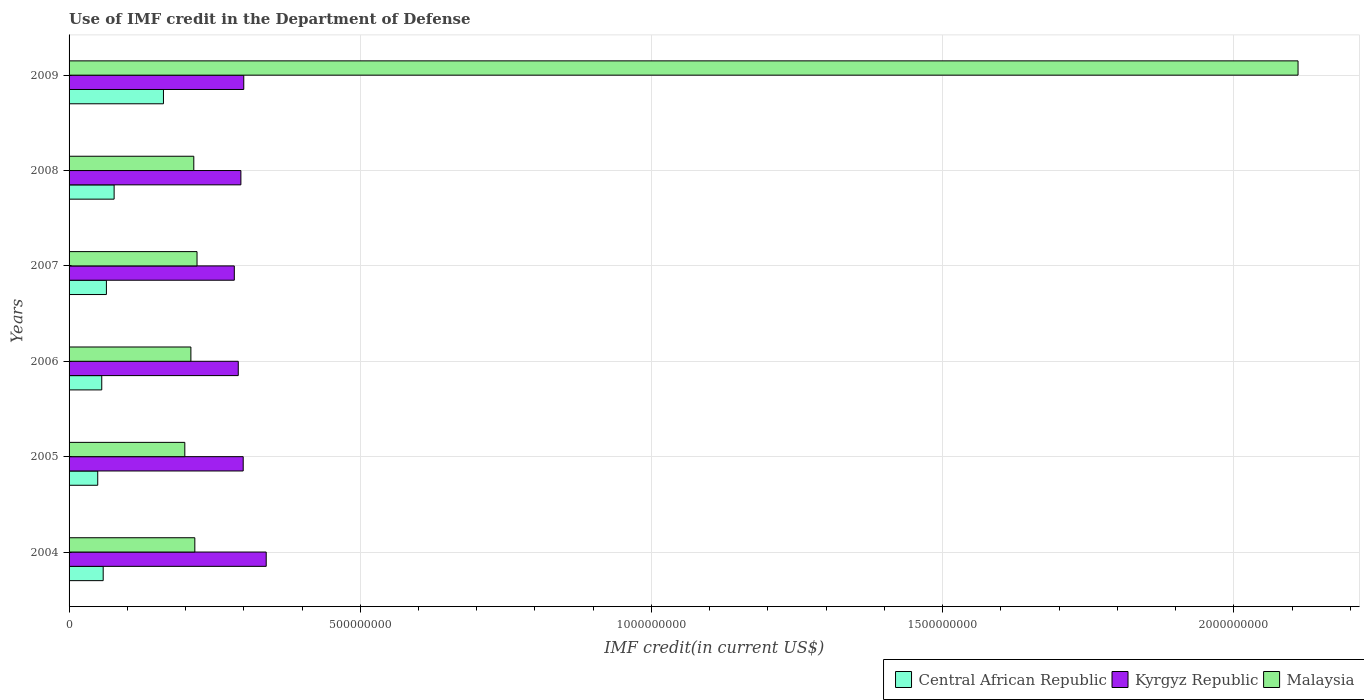How many different coloured bars are there?
Offer a very short reply. 3. Are the number of bars per tick equal to the number of legend labels?
Ensure brevity in your answer.  Yes. What is the IMF credit in the Department of Defense in Central African Republic in 2007?
Your answer should be very brief. 6.41e+07. Across all years, what is the maximum IMF credit in the Department of Defense in Central African Republic?
Your answer should be compact. 1.62e+08. Across all years, what is the minimum IMF credit in the Department of Defense in Central African Republic?
Your response must be concise. 4.92e+07. In which year was the IMF credit in the Department of Defense in Malaysia maximum?
Make the answer very short. 2009. In which year was the IMF credit in the Department of Defense in Malaysia minimum?
Give a very brief answer. 2005. What is the total IMF credit in the Department of Defense in Kyrgyz Republic in the graph?
Provide a succinct answer. 1.81e+09. What is the difference between the IMF credit in the Department of Defense in Kyrgyz Republic in 2004 and that in 2008?
Give a very brief answer. 4.35e+07. What is the difference between the IMF credit in the Department of Defense in Kyrgyz Republic in 2004 and the IMF credit in the Department of Defense in Malaysia in 2008?
Provide a succinct answer. 1.24e+08. What is the average IMF credit in the Department of Defense in Kyrgyz Republic per year?
Your answer should be compact. 3.01e+08. In the year 2009, what is the difference between the IMF credit in the Department of Defense in Kyrgyz Republic and IMF credit in the Department of Defense in Central African Republic?
Give a very brief answer. 1.38e+08. What is the ratio of the IMF credit in the Department of Defense in Central African Republic in 2007 to that in 2008?
Provide a short and direct response. 0.83. Is the IMF credit in the Department of Defense in Malaysia in 2004 less than that in 2007?
Your answer should be compact. Yes. What is the difference between the highest and the second highest IMF credit in the Department of Defense in Central African Republic?
Offer a very short reply. 8.47e+07. What is the difference between the highest and the lowest IMF credit in the Department of Defense in Kyrgyz Republic?
Keep it short and to the point. 5.48e+07. What does the 2nd bar from the top in 2009 represents?
Offer a terse response. Kyrgyz Republic. What does the 2nd bar from the bottom in 2005 represents?
Offer a terse response. Kyrgyz Republic. How many years are there in the graph?
Provide a succinct answer. 6. Does the graph contain grids?
Ensure brevity in your answer.  Yes. Where does the legend appear in the graph?
Make the answer very short. Bottom right. How many legend labels are there?
Provide a succinct answer. 3. What is the title of the graph?
Your answer should be very brief. Use of IMF credit in the Department of Defense. What is the label or title of the X-axis?
Offer a terse response. IMF credit(in current US$). What is the label or title of the Y-axis?
Your response must be concise. Years. What is the IMF credit(in current US$) in Central African Republic in 2004?
Keep it short and to the point. 5.86e+07. What is the IMF credit(in current US$) of Kyrgyz Republic in 2004?
Your response must be concise. 3.39e+08. What is the IMF credit(in current US$) of Malaysia in 2004?
Provide a succinct answer. 2.16e+08. What is the IMF credit(in current US$) of Central African Republic in 2005?
Your answer should be compact. 4.92e+07. What is the IMF credit(in current US$) of Kyrgyz Republic in 2005?
Keep it short and to the point. 2.99e+08. What is the IMF credit(in current US$) of Malaysia in 2005?
Keep it short and to the point. 1.99e+08. What is the IMF credit(in current US$) in Central African Republic in 2006?
Provide a short and direct response. 5.61e+07. What is the IMF credit(in current US$) in Kyrgyz Republic in 2006?
Your answer should be very brief. 2.91e+08. What is the IMF credit(in current US$) in Malaysia in 2006?
Make the answer very short. 2.09e+08. What is the IMF credit(in current US$) of Central African Republic in 2007?
Give a very brief answer. 6.41e+07. What is the IMF credit(in current US$) of Kyrgyz Republic in 2007?
Your answer should be compact. 2.84e+08. What is the IMF credit(in current US$) of Malaysia in 2007?
Provide a short and direct response. 2.20e+08. What is the IMF credit(in current US$) of Central African Republic in 2008?
Your response must be concise. 7.74e+07. What is the IMF credit(in current US$) of Kyrgyz Republic in 2008?
Provide a succinct answer. 2.95e+08. What is the IMF credit(in current US$) of Malaysia in 2008?
Provide a succinct answer. 2.14e+08. What is the IMF credit(in current US$) of Central African Republic in 2009?
Offer a terse response. 1.62e+08. What is the IMF credit(in current US$) of Kyrgyz Republic in 2009?
Offer a terse response. 3.00e+08. What is the IMF credit(in current US$) of Malaysia in 2009?
Provide a succinct answer. 2.11e+09. Across all years, what is the maximum IMF credit(in current US$) of Central African Republic?
Keep it short and to the point. 1.62e+08. Across all years, what is the maximum IMF credit(in current US$) of Kyrgyz Republic?
Your response must be concise. 3.39e+08. Across all years, what is the maximum IMF credit(in current US$) of Malaysia?
Provide a short and direct response. 2.11e+09. Across all years, what is the minimum IMF credit(in current US$) of Central African Republic?
Make the answer very short. 4.92e+07. Across all years, what is the minimum IMF credit(in current US$) in Kyrgyz Republic?
Provide a short and direct response. 2.84e+08. Across all years, what is the minimum IMF credit(in current US$) of Malaysia?
Give a very brief answer. 1.99e+08. What is the total IMF credit(in current US$) in Central African Republic in the graph?
Your response must be concise. 4.67e+08. What is the total IMF credit(in current US$) in Kyrgyz Republic in the graph?
Give a very brief answer. 1.81e+09. What is the total IMF credit(in current US$) in Malaysia in the graph?
Your answer should be compact. 3.17e+09. What is the difference between the IMF credit(in current US$) in Central African Republic in 2004 and that in 2005?
Keep it short and to the point. 9.38e+06. What is the difference between the IMF credit(in current US$) in Kyrgyz Republic in 2004 and that in 2005?
Keep it short and to the point. 3.95e+07. What is the difference between the IMF credit(in current US$) in Malaysia in 2004 and that in 2005?
Provide a succinct answer. 1.72e+07. What is the difference between the IMF credit(in current US$) of Central African Republic in 2004 and that in 2006?
Your response must be concise. 2.48e+06. What is the difference between the IMF credit(in current US$) of Kyrgyz Republic in 2004 and that in 2006?
Offer a terse response. 4.80e+07. What is the difference between the IMF credit(in current US$) in Malaysia in 2004 and that in 2006?
Make the answer very short. 6.76e+06. What is the difference between the IMF credit(in current US$) in Central African Republic in 2004 and that in 2007?
Ensure brevity in your answer.  -5.52e+06. What is the difference between the IMF credit(in current US$) in Kyrgyz Republic in 2004 and that in 2007?
Offer a terse response. 5.48e+07. What is the difference between the IMF credit(in current US$) of Malaysia in 2004 and that in 2007?
Ensure brevity in your answer.  -3.79e+06. What is the difference between the IMF credit(in current US$) in Central African Republic in 2004 and that in 2008?
Offer a terse response. -1.88e+07. What is the difference between the IMF credit(in current US$) in Kyrgyz Republic in 2004 and that in 2008?
Keep it short and to the point. 4.35e+07. What is the difference between the IMF credit(in current US$) in Malaysia in 2004 and that in 2008?
Keep it short and to the point. 1.77e+06. What is the difference between the IMF credit(in current US$) of Central African Republic in 2004 and that in 2009?
Keep it short and to the point. -1.03e+08. What is the difference between the IMF credit(in current US$) in Kyrgyz Republic in 2004 and that in 2009?
Your answer should be compact. 3.86e+07. What is the difference between the IMF credit(in current US$) in Malaysia in 2004 and that in 2009?
Give a very brief answer. -1.89e+09. What is the difference between the IMF credit(in current US$) of Central African Republic in 2005 and that in 2006?
Make the answer very short. -6.90e+06. What is the difference between the IMF credit(in current US$) of Kyrgyz Republic in 2005 and that in 2006?
Give a very brief answer. 8.46e+06. What is the difference between the IMF credit(in current US$) of Malaysia in 2005 and that in 2006?
Your answer should be compact. -1.04e+07. What is the difference between the IMF credit(in current US$) in Central African Republic in 2005 and that in 2007?
Your answer should be very brief. -1.49e+07. What is the difference between the IMF credit(in current US$) in Kyrgyz Republic in 2005 and that in 2007?
Your response must be concise. 1.53e+07. What is the difference between the IMF credit(in current US$) in Malaysia in 2005 and that in 2007?
Give a very brief answer. -2.10e+07. What is the difference between the IMF credit(in current US$) in Central African Republic in 2005 and that in 2008?
Give a very brief answer. -2.82e+07. What is the difference between the IMF credit(in current US$) in Kyrgyz Republic in 2005 and that in 2008?
Your answer should be very brief. 3.97e+06. What is the difference between the IMF credit(in current US$) in Malaysia in 2005 and that in 2008?
Offer a terse response. -1.54e+07. What is the difference between the IMF credit(in current US$) of Central African Republic in 2005 and that in 2009?
Make the answer very short. -1.13e+08. What is the difference between the IMF credit(in current US$) of Kyrgyz Republic in 2005 and that in 2009?
Provide a succinct answer. -9.68e+05. What is the difference between the IMF credit(in current US$) of Malaysia in 2005 and that in 2009?
Keep it short and to the point. -1.91e+09. What is the difference between the IMF credit(in current US$) of Central African Republic in 2006 and that in 2007?
Provide a succinct answer. -8.00e+06. What is the difference between the IMF credit(in current US$) in Kyrgyz Republic in 2006 and that in 2007?
Offer a very short reply. 6.81e+06. What is the difference between the IMF credit(in current US$) in Malaysia in 2006 and that in 2007?
Your response must be concise. -1.05e+07. What is the difference between the IMF credit(in current US$) in Central African Republic in 2006 and that in 2008?
Your answer should be compact. -2.13e+07. What is the difference between the IMF credit(in current US$) in Kyrgyz Republic in 2006 and that in 2008?
Your answer should be very brief. -4.50e+06. What is the difference between the IMF credit(in current US$) of Malaysia in 2006 and that in 2008?
Give a very brief answer. -4.99e+06. What is the difference between the IMF credit(in current US$) of Central African Republic in 2006 and that in 2009?
Give a very brief answer. -1.06e+08. What is the difference between the IMF credit(in current US$) of Kyrgyz Republic in 2006 and that in 2009?
Offer a terse response. -9.43e+06. What is the difference between the IMF credit(in current US$) of Malaysia in 2006 and that in 2009?
Your answer should be very brief. -1.90e+09. What is the difference between the IMF credit(in current US$) of Central African Republic in 2007 and that in 2008?
Your answer should be compact. -1.33e+07. What is the difference between the IMF credit(in current US$) in Kyrgyz Republic in 2007 and that in 2008?
Provide a succinct answer. -1.13e+07. What is the difference between the IMF credit(in current US$) of Malaysia in 2007 and that in 2008?
Provide a succinct answer. 5.56e+06. What is the difference between the IMF credit(in current US$) in Central African Republic in 2007 and that in 2009?
Provide a succinct answer. -9.80e+07. What is the difference between the IMF credit(in current US$) in Kyrgyz Republic in 2007 and that in 2009?
Offer a terse response. -1.62e+07. What is the difference between the IMF credit(in current US$) in Malaysia in 2007 and that in 2009?
Offer a terse response. -1.89e+09. What is the difference between the IMF credit(in current US$) in Central African Republic in 2008 and that in 2009?
Keep it short and to the point. -8.47e+07. What is the difference between the IMF credit(in current US$) in Kyrgyz Republic in 2008 and that in 2009?
Ensure brevity in your answer.  -4.93e+06. What is the difference between the IMF credit(in current US$) in Malaysia in 2008 and that in 2009?
Your answer should be compact. -1.90e+09. What is the difference between the IMF credit(in current US$) of Central African Republic in 2004 and the IMF credit(in current US$) of Kyrgyz Republic in 2005?
Your response must be concise. -2.40e+08. What is the difference between the IMF credit(in current US$) of Central African Republic in 2004 and the IMF credit(in current US$) of Malaysia in 2005?
Offer a very short reply. -1.40e+08. What is the difference between the IMF credit(in current US$) in Kyrgyz Republic in 2004 and the IMF credit(in current US$) in Malaysia in 2005?
Give a very brief answer. 1.40e+08. What is the difference between the IMF credit(in current US$) of Central African Republic in 2004 and the IMF credit(in current US$) of Kyrgyz Republic in 2006?
Your answer should be compact. -2.32e+08. What is the difference between the IMF credit(in current US$) in Central African Republic in 2004 and the IMF credit(in current US$) in Malaysia in 2006?
Your response must be concise. -1.51e+08. What is the difference between the IMF credit(in current US$) of Kyrgyz Republic in 2004 and the IMF credit(in current US$) of Malaysia in 2006?
Your answer should be very brief. 1.29e+08. What is the difference between the IMF credit(in current US$) of Central African Republic in 2004 and the IMF credit(in current US$) of Kyrgyz Republic in 2007?
Provide a short and direct response. -2.25e+08. What is the difference between the IMF credit(in current US$) of Central African Republic in 2004 and the IMF credit(in current US$) of Malaysia in 2007?
Offer a terse response. -1.61e+08. What is the difference between the IMF credit(in current US$) of Kyrgyz Republic in 2004 and the IMF credit(in current US$) of Malaysia in 2007?
Provide a succinct answer. 1.19e+08. What is the difference between the IMF credit(in current US$) in Central African Republic in 2004 and the IMF credit(in current US$) in Kyrgyz Republic in 2008?
Provide a succinct answer. -2.36e+08. What is the difference between the IMF credit(in current US$) in Central African Republic in 2004 and the IMF credit(in current US$) in Malaysia in 2008?
Keep it short and to the point. -1.56e+08. What is the difference between the IMF credit(in current US$) of Kyrgyz Republic in 2004 and the IMF credit(in current US$) of Malaysia in 2008?
Keep it short and to the point. 1.24e+08. What is the difference between the IMF credit(in current US$) of Central African Republic in 2004 and the IMF credit(in current US$) of Kyrgyz Republic in 2009?
Offer a very short reply. -2.41e+08. What is the difference between the IMF credit(in current US$) in Central African Republic in 2004 and the IMF credit(in current US$) in Malaysia in 2009?
Offer a terse response. -2.05e+09. What is the difference between the IMF credit(in current US$) of Kyrgyz Republic in 2004 and the IMF credit(in current US$) of Malaysia in 2009?
Give a very brief answer. -1.77e+09. What is the difference between the IMF credit(in current US$) in Central African Republic in 2005 and the IMF credit(in current US$) in Kyrgyz Republic in 2006?
Ensure brevity in your answer.  -2.41e+08. What is the difference between the IMF credit(in current US$) in Central African Republic in 2005 and the IMF credit(in current US$) in Malaysia in 2006?
Offer a very short reply. -1.60e+08. What is the difference between the IMF credit(in current US$) of Kyrgyz Republic in 2005 and the IMF credit(in current US$) of Malaysia in 2006?
Give a very brief answer. 8.98e+07. What is the difference between the IMF credit(in current US$) of Central African Republic in 2005 and the IMF credit(in current US$) of Kyrgyz Republic in 2007?
Provide a short and direct response. -2.35e+08. What is the difference between the IMF credit(in current US$) of Central African Republic in 2005 and the IMF credit(in current US$) of Malaysia in 2007?
Keep it short and to the point. -1.71e+08. What is the difference between the IMF credit(in current US$) in Kyrgyz Republic in 2005 and the IMF credit(in current US$) in Malaysia in 2007?
Offer a terse response. 7.93e+07. What is the difference between the IMF credit(in current US$) in Central African Republic in 2005 and the IMF credit(in current US$) in Kyrgyz Republic in 2008?
Make the answer very short. -2.46e+08. What is the difference between the IMF credit(in current US$) in Central African Republic in 2005 and the IMF credit(in current US$) in Malaysia in 2008?
Your response must be concise. -1.65e+08. What is the difference between the IMF credit(in current US$) in Kyrgyz Republic in 2005 and the IMF credit(in current US$) in Malaysia in 2008?
Your response must be concise. 8.48e+07. What is the difference between the IMF credit(in current US$) in Central African Republic in 2005 and the IMF credit(in current US$) in Kyrgyz Republic in 2009?
Give a very brief answer. -2.51e+08. What is the difference between the IMF credit(in current US$) of Central African Republic in 2005 and the IMF credit(in current US$) of Malaysia in 2009?
Your response must be concise. -2.06e+09. What is the difference between the IMF credit(in current US$) in Kyrgyz Republic in 2005 and the IMF credit(in current US$) in Malaysia in 2009?
Keep it short and to the point. -1.81e+09. What is the difference between the IMF credit(in current US$) in Central African Republic in 2006 and the IMF credit(in current US$) in Kyrgyz Republic in 2007?
Provide a short and direct response. -2.28e+08. What is the difference between the IMF credit(in current US$) of Central African Republic in 2006 and the IMF credit(in current US$) of Malaysia in 2007?
Make the answer very short. -1.64e+08. What is the difference between the IMF credit(in current US$) in Kyrgyz Republic in 2006 and the IMF credit(in current US$) in Malaysia in 2007?
Make the answer very short. 7.08e+07. What is the difference between the IMF credit(in current US$) of Central African Republic in 2006 and the IMF credit(in current US$) of Kyrgyz Republic in 2008?
Keep it short and to the point. -2.39e+08. What is the difference between the IMF credit(in current US$) of Central African Republic in 2006 and the IMF credit(in current US$) of Malaysia in 2008?
Provide a succinct answer. -1.58e+08. What is the difference between the IMF credit(in current US$) of Kyrgyz Republic in 2006 and the IMF credit(in current US$) of Malaysia in 2008?
Your answer should be compact. 7.64e+07. What is the difference between the IMF credit(in current US$) in Central African Republic in 2006 and the IMF credit(in current US$) in Kyrgyz Republic in 2009?
Make the answer very short. -2.44e+08. What is the difference between the IMF credit(in current US$) of Central African Republic in 2006 and the IMF credit(in current US$) of Malaysia in 2009?
Provide a short and direct response. -2.05e+09. What is the difference between the IMF credit(in current US$) in Kyrgyz Republic in 2006 and the IMF credit(in current US$) in Malaysia in 2009?
Offer a terse response. -1.82e+09. What is the difference between the IMF credit(in current US$) in Central African Republic in 2007 and the IMF credit(in current US$) in Kyrgyz Republic in 2008?
Give a very brief answer. -2.31e+08. What is the difference between the IMF credit(in current US$) in Central African Republic in 2007 and the IMF credit(in current US$) in Malaysia in 2008?
Offer a very short reply. -1.50e+08. What is the difference between the IMF credit(in current US$) of Kyrgyz Republic in 2007 and the IMF credit(in current US$) of Malaysia in 2008?
Your answer should be compact. 6.96e+07. What is the difference between the IMF credit(in current US$) in Central African Republic in 2007 and the IMF credit(in current US$) in Kyrgyz Republic in 2009?
Ensure brevity in your answer.  -2.36e+08. What is the difference between the IMF credit(in current US$) of Central African Republic in 2007 and the IMF credit(in current US$) of Malaysia in 2009?
Offer a very short reply. -2.05e+09. What is the difference between the IMF credit(in current US$) of Kyrgyz Republic in 2007 and the IMF credit(in current US$) of Malaysia in 2009?
Your response must be concise. -1.83e+09. What is the difference between the IMF credit(in current US$) in Central African Republic in 2008 and the IMF credit(in current US$) in Kyrgyz Republic in 2009?
Give a very brief answer. -2.23e+08. What is the difference between the IMF credit(in current US$) of Central African Republic in 2008 and the IMF credit(in current US$) of Malaysia in 2009?
Ensure brevity in your answer.  -2.03e+09. What is the difference between the IMF credit(in current US$) in Kyrgyz Republic in 2008 and the IMF credit(in current US$) in Malaysia in 2009?
Your response must be concise. -1.82e+09. What is the average IMF credit(in current US$) in Central African Republic per year?
Your answer should be very brief. 7.79e+07. What is the average IMF credit(in current US$) of Kyrgyz Republic per year?
Provide a short and direct response. 3.01e+08. What is the average IMF credit(in current US$) in Malaysia per year?
Your answer should be very brief. 5.28e+08. In the year 2004, what is the difference between the IMF credit(in current US$) of Central African Republic and IMF credit(in current US$) of Kyrgyz Republic?
Offer a terse response. -2.80e+08. In the year 2004, what is the difference between the IMF credit(in current US$) of Central African Republic and IMF credit(in current US$) of Malaysia?
Offer a terse response. -1.57e+08. In the year 2004, what is the difference between the IMF credit(in current US$) of Kyrgyz Republic and IMF credit(in current US$) of Malaysia?
Your answer should be very brief. 1.23e+08. In the year 2005, what is the difference between the IMF credit(in current US$) of Central African Republic and IMF credit(in current US$) of Kyrgyz Republic?
Provide a succinct answer. -2.50e+08. In the year 2005, what is the difference between the IMF credit(in current US$) in Central African Republic and IMF credit(in current US$) in Malaysia?
Your response must be concise. -1.50e+08. In the year 2005, what is the difference between the IMF credit(in current US$) of Kyrgyz Republic and IMF credit(in current US$) of Malaysia?
Provide a short and direct response. 1.00e+08. In the year 2006, what is the difference between the IMF credit(in current US$) of Central African Republic and IMF credit(in current US$) of Kyrgyz Republic?
Your answer should be very brief. -2.34e+08. In the year 2006, what is the difference between the IMF credit(in current US$) of Central African Republic and IMF credit(in current US$) of Malaysia?
Keep it short and to the point. -1.53e+08. In the year 2006, what is the difference between the IMF credit(in current US$) in Kyrgyz Republic and IMF credit(in current US$) in Malaysia?
Your answer should be compact. 8.14e+07. In the year 2007, what is the difference between the IMF credit(in current US$) of Central African Republic and IMF credit(in current US$) of Kyrgyz Republic?
Your answer should be compact. -2.20e+08. In the year 2007, what is the difference between the IMF credit(in current US$) of Central African Republic and IMF credit(in current US$) of Malaysia?
Make the answer very short. -1.56e+08. In the year 2007, what is the difference between the IMF credit(in current US$) in Kyrgyz Republic and IMF credit(in current US$) in Malaysia?
Offer a terse response. 6.40e+07. In the year 2008, what is the difference between the IMF credit(in current US$) in Central African Republic and IMF credit(in current US$) in Kyrgyz Republic?
Offer a very short reply. -2.18e+08. In the year 2008, what is the difference between the IMF credit(in current US$) of Central African Republic and IMF credit(in current US$) of Malaysia?
Keep it short and to the point. -1.37e+08. In the year 2008, what is the difference between the IMF credit(in current US$) of Kyrgyz Republic and IMF credit(in current US$) of Malaysia?
Offer a very short reply. 8.09e+07. In the year 2009, what is the difference between the IMF credit(in current US$) in Central African Republic and IMF credit(in current US$) in Kyrgyz Republic?
Your response must be concise. -1.38e+08. In the year 2009, what is the difference between the IMF credit(in current US$) in Central African Republic and IMF credit(in current US$) in Malaysia?
Provide a short and direct response. -1.95e+09. In the year 2009, what is the difference between the IMF credit(in current US$) in Kyrgyz Republic and IMF credit(in current US$) in Malaysia?
Ensure brevity in your answer.  -1.81e+09. What is the ratio of the IMF credit(in current US$) in Central African Republic in 2004 to that in 2005?
Give a very brief answer. 1.19. What is the ratio of the IMF credit(in current US$) of Kyrgyz Republic in 2004 to that in 2005?
Make the answer very short. 1.13. What is the ratio of the IMF credit(in current US$) of Malaysia in 2004 to that in 2005?
Provide a succinct answer. 1.09. What is the ratio of the IMF credit(in current US$) in Central African Republic in 2004 to that in 2006?
Provide a succinct answer. 1.04. What is the ratio of the IMF credit(in current US$) in Kyrgyz Republic in 2004 to that in 2006?
Provide a short and direct response. 1.17. What is the ratio of the IMF credit(in current US$) in Malaysia in 2004 to that in 2006?
Offer a terse response. 1.03. What is the ratio of the IMF credit(in current US$) of Central African Republic in 2004 to that in 2007?
Keep it short and to the point. 0.91. What is the ratio of the IMF credit(in current US$) in Kyrgyz Republic in 2004 to that in 2007?
Keep it short and to the point. 1.19. What is the ratio of the IMF credit(in current US$) in Malaysia in 2004 to that in 2007?
Provide a short and direct response. 0.98. What is the ratio of the IMF credit(in current US$) of Central African Republic in 2004 to that in 2008?
Provide a short and direct response. 0.76. What is the ratio of the IMF credit(in current US$) of Kyrgyz Republic in 2004 to that in 2008?
Your response must be concise. 1.15. What is the ratio of the IMF credit(in current US$) in Malaysia in 2004 to that in 2008?
Ensure brevity in your answer.  1.01. What is the ratio of the IMF credit(in current US$) of Central African Republic in 2004 to that in 2009?
Ensure brevity in your answer.  0.36. What is the ratio of the IMF credit(in current US$) of Kyrgyz Republic in 2004 to that in 2009?
Offer a very short reply. 1.13. What is the ratio of the IMF credit(in current US$) of Malaysia in 2004 to that in 2009?
Ensure brevity in your answer.  0.1. What is the ratio of the IMF credit(in current US$) of Central African Republic in 2005 to that in 2006?
Your answer should be compact. 0.88. What is the ratio of the IMF credit(in current US$) of Kyrgyz Republic in 2005 to that in 2006?
Your answer should be very brief. 1.03. What is the ratio of the IMF credit(in current US$) in Malaysia in 2005 to that in 2006?
Offer a terse response. 0.95. What is the ratio of the IMF credit(in current US$) in Central African Republic in 2005 to that in 2007?
Offer a very short reply. 0.77. What is the ratio of the IMF credit(in current US$) in Kyrgyz Republic in 2005 to that in 2007?
Make the answer very short. 1.05. What is the ratio of the IMF credit(in current US$) of Malaysia in 2005 to that in 2007?
Ensure brevity in your answer.  0.9. What is the ratio of the IMF credit(in current US$) in Central African Republic in 2005 to that in 2008?
Keep it short and to the point. 0.64. What is the ratio of the IMF credit(in current US$) of Kyrgyz Republic in 2005 to that in 2008?
Keep it short and to the point. 1.01. What is the ratio of the IMF credit(in current US$) of Malaysia in 2005 to that in 2008?
Ensure brevity in your answer.  0.93. What is the ratio of the IMF credit(in current US$) in Central African Republic in 2005 to that in 2009?
Provide a succinct answer. 0.3. What is the ratio of the IMF credit(in current US$) of Malaysia in 2005 to that in 2009?
Keep it short and to the point. 0.09. What is the ratio of the IMF credit(in current US$) in Central African Republic in 2006 to that in 2007?
Provide a short and direct response. 0.88. What is the ratio of the IMF credit(in current US$) of Kyrgyz Republic in 2006 to that in 2007?
Give a very brief answer. 1.02. What is the ratio of the IMF credit(in current US$) of Central African Republic in 2006 to that in 2008?
Ensure brevity in your answer.  0.73. What is the ratio of the IMF credit(in current US$) of Kyrgyz Republic in 2006 to that in 2008?
Your answer should be compact. 0.98. What is the ratio of the IMF credit(in current US$) in Malaysia in 2006 to that in 2008?
Your response must be concise. 0.98. What is the ratio of the IMF credit(in current US$) of Central African Republic in 2006 to that in 2009?
Offer a very short reply. 0.35. What is the ratio of the IMF credit(in current US$) of Kyrgyz Republic in 2006 to that in 2009?
Give a very brief answer. 0.97. What is the ratio of the IMF credit(in current US$) of Malaysia in 2006 to that in 2009?
Your answer should be very brief. 0.1. What is the ratio of the IMF credit(in current US$) of Central African Republic in 2007 to that in 2008?
Give a very brief answer. 0.83. What is the ratio of the IMF credit(in current US$) of Kyrgyz Republic in 2007 to that in 2008?
Ensure brevity in your answer.  0.96. What is the ratio of the IMF credit(in current US$) in Central African Republic in 2007 to that in 2009?
Keep it short and to the point. 0.4. What is the ratio of the IMF credit(in current US$) of Kyrgyz Republic in 2007 to that in 2009?
Keep it short and to the point. 0.95. What is the ratio of the IMF credit(in current US$) in Malaysia in 2007 to that in 2009?
Offer a terse response. 0.1. What is the ratio of the IMF credit(in current US$) of Central African Republic in 2008 to that in 2009?
Your answer should be compact. 0.48. What is the ratio of the IMF credit(in current US$) in Kyrgyz Republic in 2008 to that in 2009?
Your response must be concise. 0.98. What is the ratio of the IMF credit(in current US$) in Malaysia in 2008 to that in 2009?
Offer a very short reply. 0.1. What is the difference between the highest and the second highest IMF credit(in current US$) of Central African Republic?
Provide a succinct answer. 8.47e+07. What is the difference between the highest and the second highest IMF credit(in current US$) in Kyrgyz Republic?
Offer a terse response. 3.86e+07. What is the difference between the highest and the second highest IMF credit(in current US$) of Malaysia?
Offer a very short reply. 1.89e+09. What is the difference between the highest and the lowest IMF credit(in current US$) in Central African Republic?
Offer a terse response. 1.13e+08. What is the difference between the highest and the lowest IMF credit(in current US$) of Kyrgyz Republic?
Offer a very short reply. 5.48e+07. What is the difference between the highest and the lowest IMF credit(in current US$) in Malaysia?
Offer a terse response. 1.91e+09. 